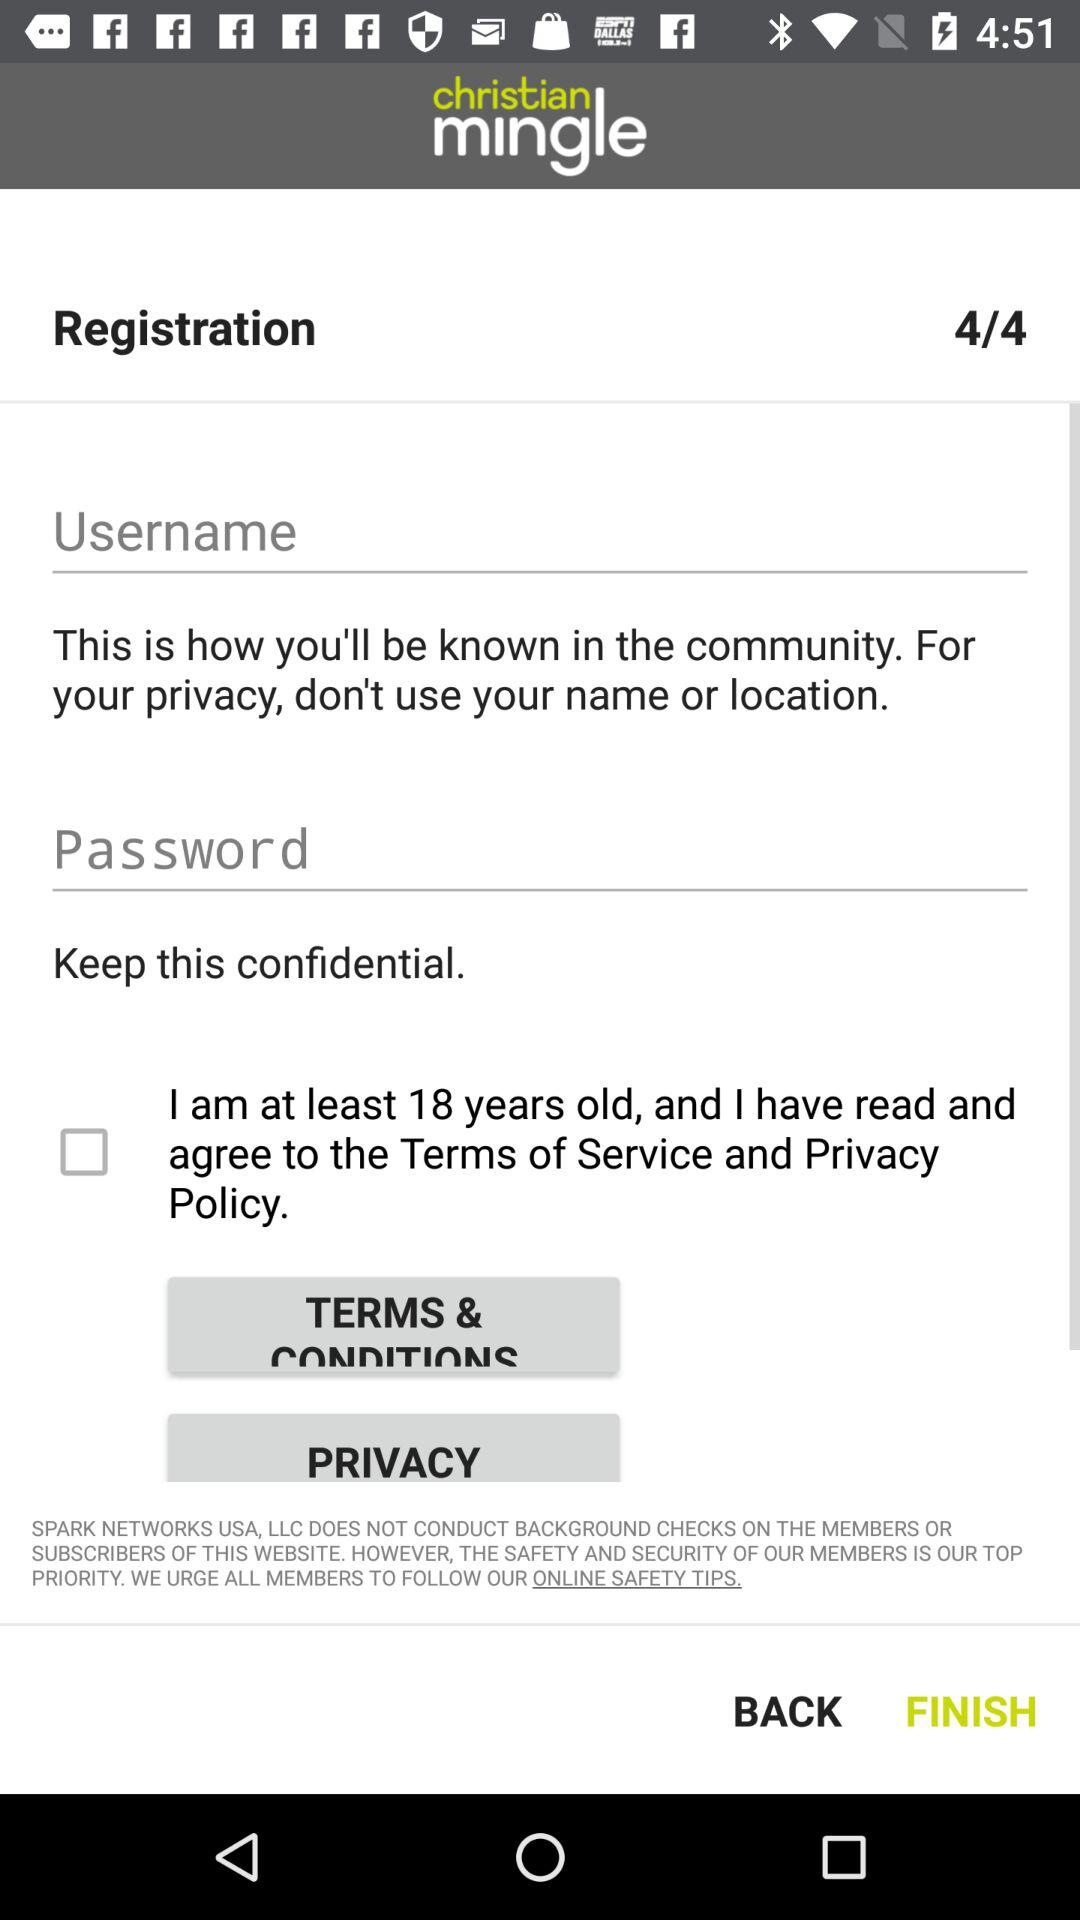How many text inputs are required to complete registration?
Answer the question using a single word or phrase. 2 